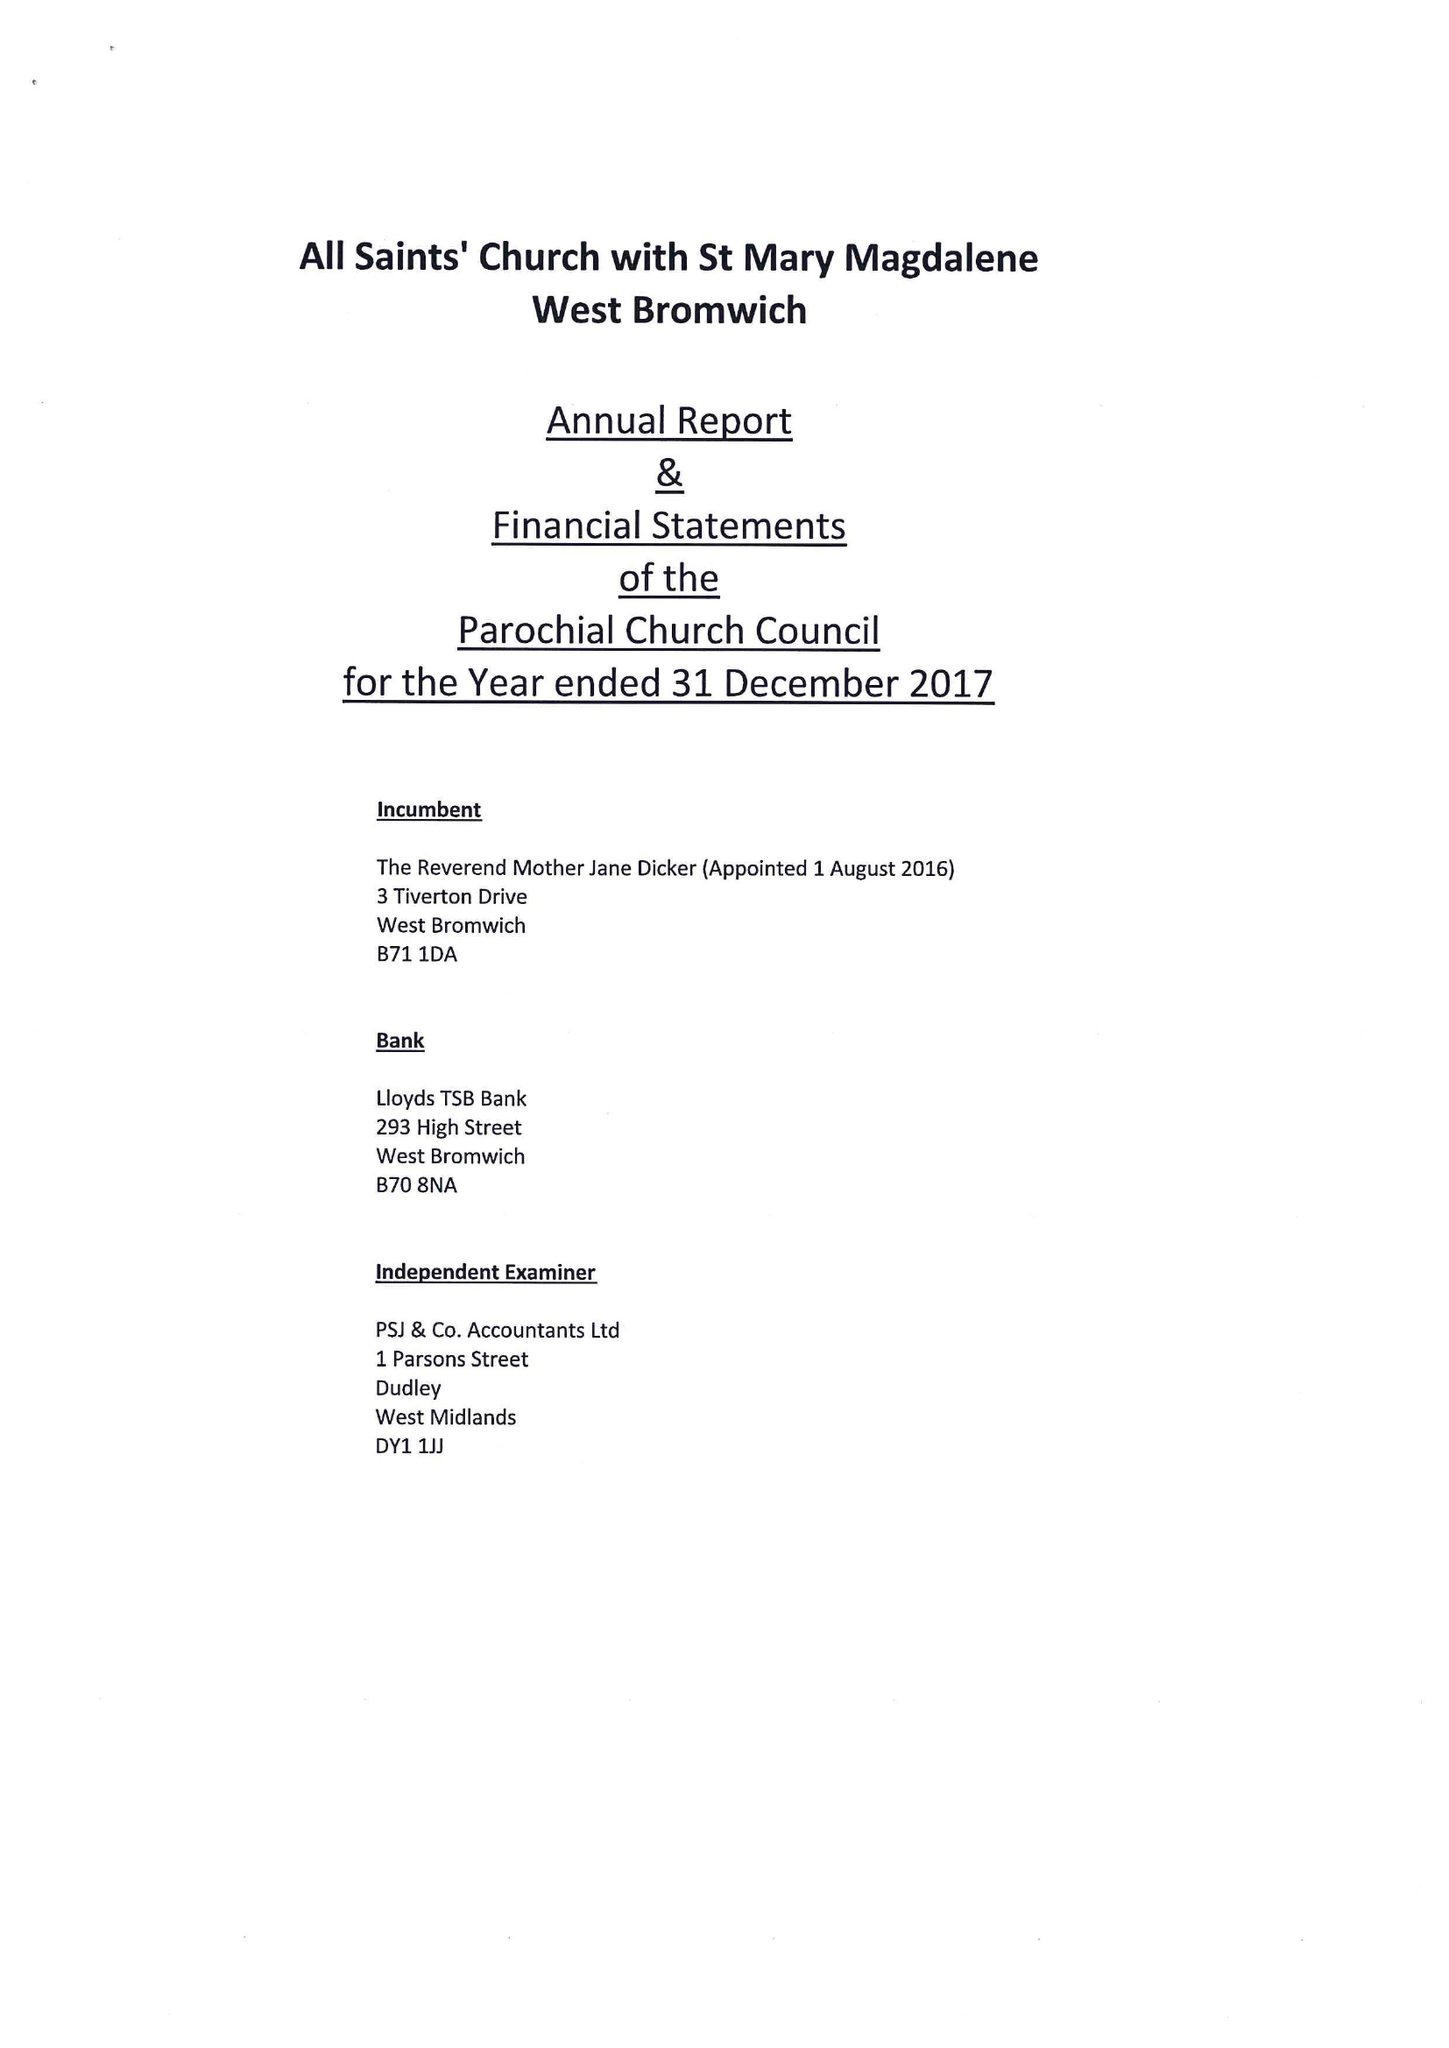What is the value for the charity_number?
Answer the question using a single word or phrase. 1153167 